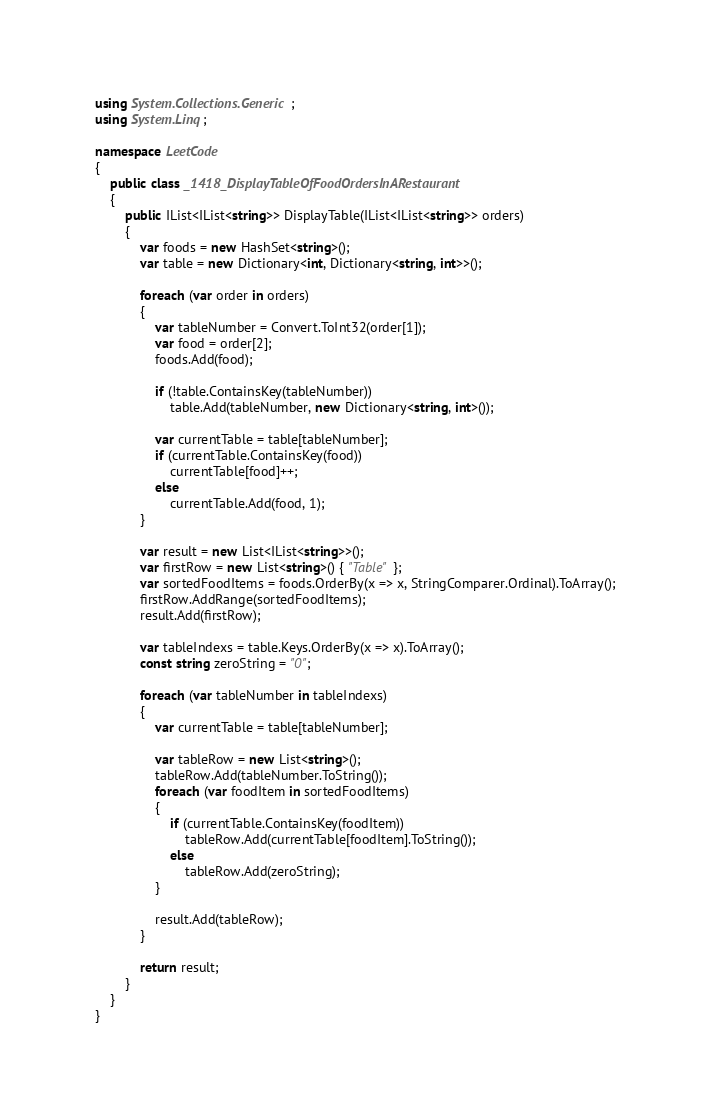Convert code to text. <code><loc_0><loc_0><loc_500><loc_500><_C#_>using System.Collections.Generic;
using System.Linq;

namespace LeetCode
{
    public class _1418_DisplayTableOfFoodOrdersInARestaurant
    {
        public IList<IList<string>> DisplayTable(IList<IList<string>> orders)
        {
            var foods = new HashSet<string>();
            var table = new Dictionary<int, Dictionary<string, int>>();

            foreach (var order in orders)
            {
                var tableNumber = Convert.ToInt32(order[1]);
                var food = order[2];
                foods.Add(food);

                if (!table.ContainsKey(tableNumber))
                    table.Add(tableNumber, new Dictionary<string, int>());

                var currentTable = table[tableNumber];
                if (currentTable.ContainsKey(food))
                    currentTable[food]++;
                else
                    currentTable.Add(food, 1);
            }

            var result = new List<IList<string>>();
            var firstRow = new List<string>() { "Table" };
            var sortedFoodItems = foods.OrderBy(x => x, StringComparer.Ordinal).ToArray();
            firstRow.AddRange(sortedFoodItems);
            result.Add(firstRow);

            var tableIndexs = table.Keys.OrderBy(x => x).ToArray();
            const string zeroString = "0";

            foreach (var tableNumber in tableIndexs)
            {
                var currentTable = table[tableNumber];

                var tableRow = new List<string>();
                tableRow.Add(tableNumber.ToString());
                foreach (var foodItem in sortedFoodItems)
                {
                    if (currentTable.ContainsKey(foodItem))
                        tableRow.Add(currentTable[foodItem].ToString());
                    else
                        tableRow.Add(zeroString);
                }

                result.Add(tableRow);
            }

            return result;
        }
    }
}
</code> 